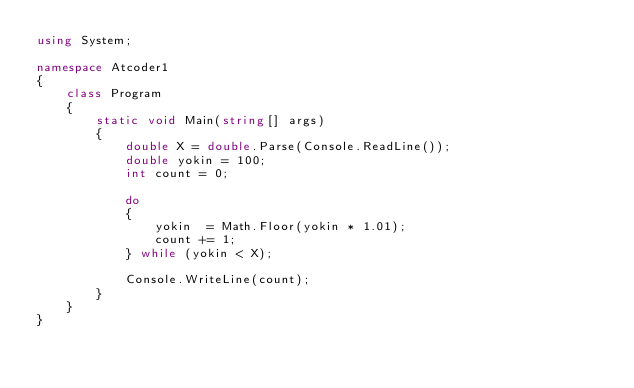Convert code to text. <code><loc_0><loc_0><loc_500><loc_500><_C#_>using System;

namespace Atcoder1
{
    class Program
    {
        static void Main(string[] args)
        {
            double X = double.Parse(Console.ReadLine());
            double yokin = 100;
            int count = 0;

            do
            {
                yokin  = Math.Floor(yokin * 1.01);
                count += 1;
            } while (yokin < X);

            Console.WriteLine(count);
        }
    }
}</code> 